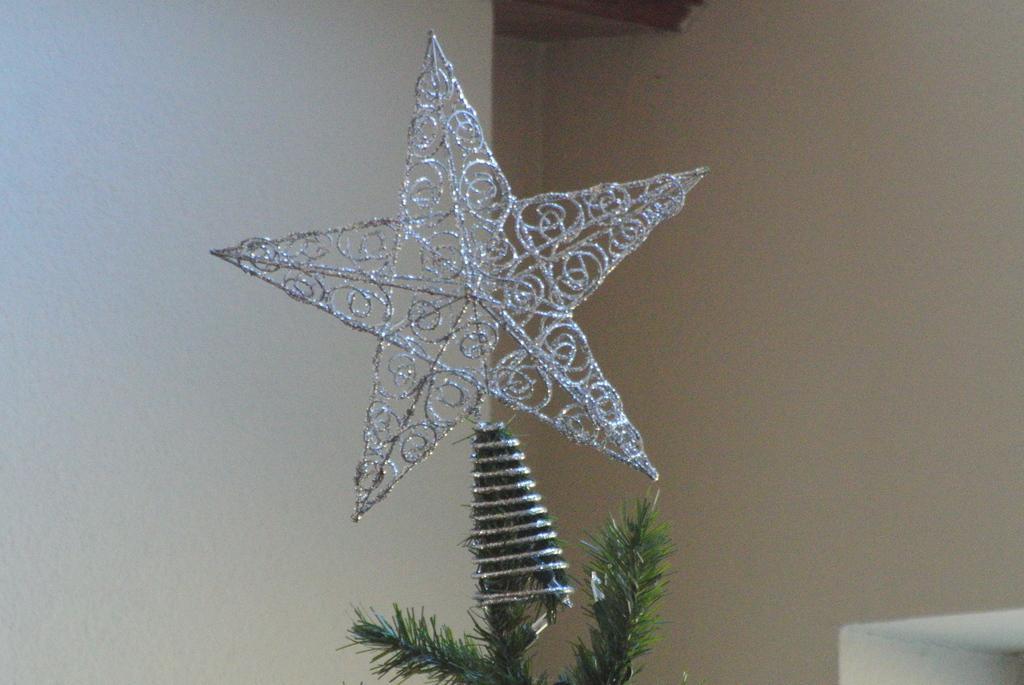In one or two sentences, can you explain what this image depicts? this picture is taken inside the room. In this image, in the middle, we can see a plant, on the plant, we can see a star. In the right corner, we can see an object which is in white color. In the background, we can see a wall. 